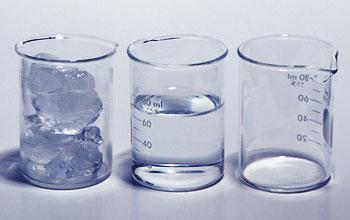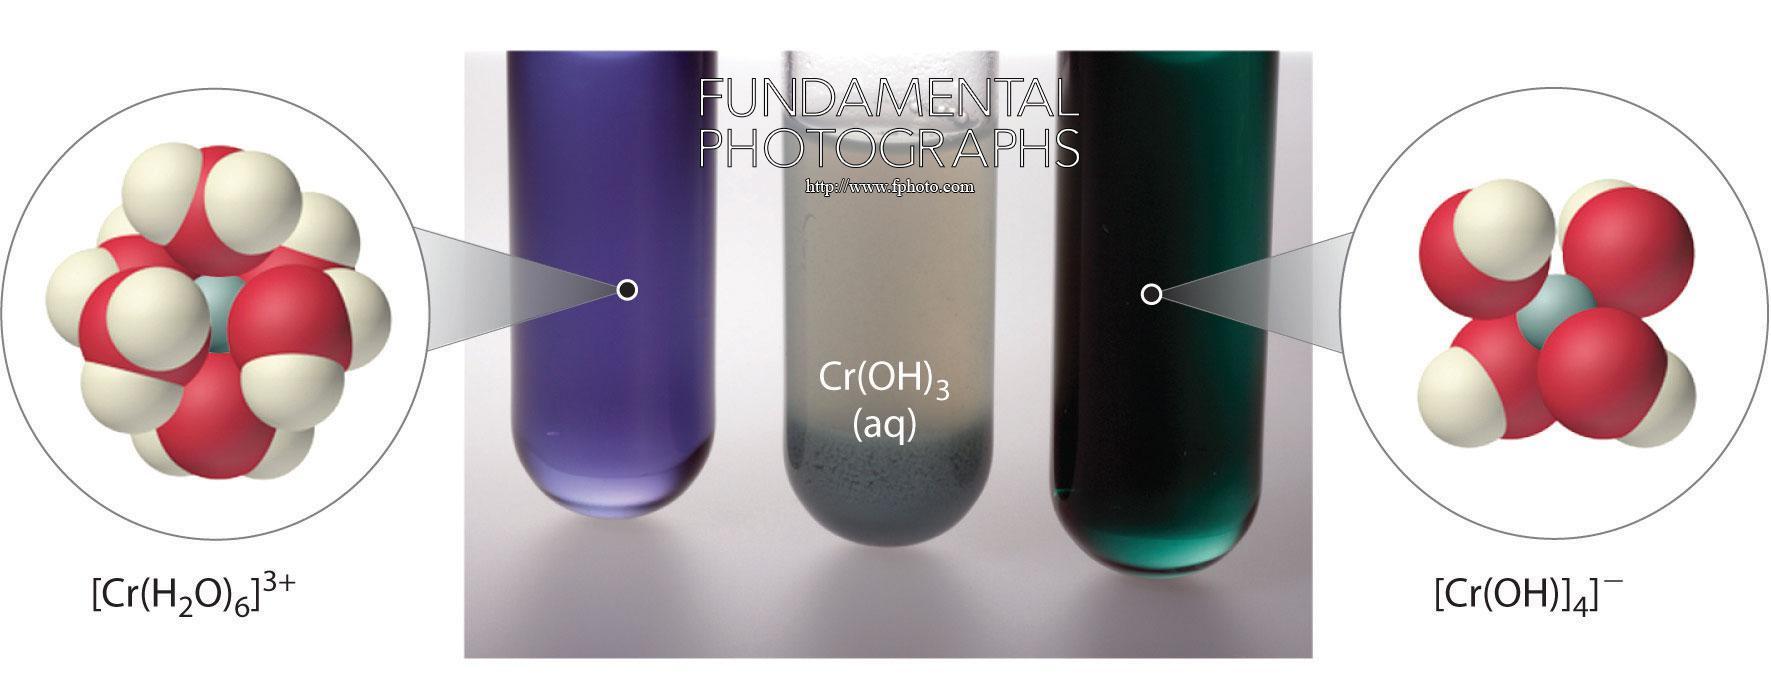The first image is the image on the left, the second image is the image on the right. Considering the images on both sides, is "All images show beakers and all beakers contain colored liquids." valid? Answer yes or no. No. 